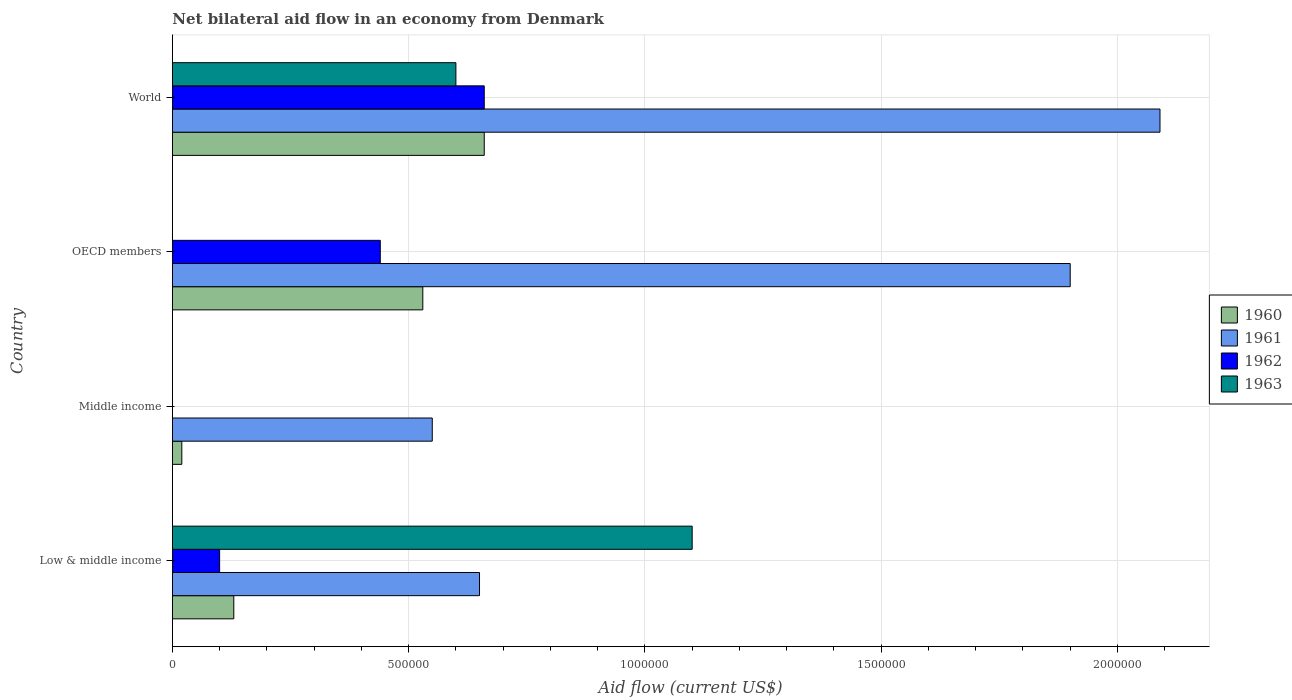How many different coloured bars are there?
Keep it short and to the point. 4. What is the label of the 4th group of bars from the top?
Your answer should be compact. Low & middle income. What is the net bilateral aid flow in 1961 in OECD members?
Your answer should be compact. 1.90e+06. Across all countries, what is the maximum net bilateral aid flow in 1960?
Offer a very short reply. 6.60e+05. What is the total net bilateral aid flow in 1960 in the graph?
Ensure brevity in your answer.  1.34e+06. What is the difference between the net bilateral aid flow in 1963 in Low & middle income and that in World?
Provide a succinct answer. 5.00e+05. What is the difference between the net bilateral aid flow in 1962 in OECD members and the net bilateral aid flow in 1960 in Middle income?
Keep it short and to the point. 4.20e+05. In how many countries, is the net bilateral aid flow in 1960 greater than 100000 US$?
Offer a very short reply. 3. What is the ratio of the net bilateral aid flow in 1961 in Low & middle income to that in World?
Give a very brief answer. 0.31. Is the net bilateral aid flow in 1960 in Low & middle income less than that in Middle income?
Your response must be concise. No. Is the difference between the net bilateral aid flow in 1962 in Low & middle income and World greater than the difference between the net bilateral aid flow in 1963 in Low & middle income and World?
Your answer should be compact. No. What is the difference between the highest and the lowest net bilateral aid flow in 1960?
Offer a very short reply. 6.40e+05. In how many countries, is the net bilateral aid flow in 1962 greater than the average net bilateral aid flow in 1962 taken over all countries?
Provide a succinct answer. 2. Is the sum of the net bilateral aid flow in 1961 in Middle income and OECD members greater than the maximum net bilateral aid flow in 1960 across all countries?
Offer a very short reply. Yes. Is it the case that in every country, the sum of the net bilateral aid flow in 1961 and net bilateral aid flow in 1960 is greater than the net bilateral aid flow in 1963?
Your response must be concise. No. Are the values on the major ticks of X-axis written in scientific E-notation?
Your answer should be compact. No. Does the graph contain any zero values?
Your answer should be compact. Yes. Where does the legend appear in the graph?
Provide a short and direct response. Center right. How many legend labels are there?
Your answer should be very brief. 4. What is the title of the graph?
Provide a succinct answer. Net bilateral aid flow in an economy from Denmark. What is the label or title of the X-axis?
Give a very brief answer. Aid flow (current US$). What is the label or title of the Y-axis?
Your answer should be very brief. Country. What is the Aid flow (current US$) of 1961 in Low & middle income?
Your answer should be very brief. 6.50e+05. What is the Aid flow (current US$) of 1962 in Low & middle income?
Ensure brevity in your answer.  1.00e+05. What is the Aid flow (current US$) of 1963 in Low & middle income?
Your answer should be very brief. 1.10e+06. What is the Aid flow (current US$) of 1960 in Middle income?
Provide a short and direct response. 2.00e+04. What is the Aid flow (current US$) of 1960 in OECD members?
Give a very brief answer. 5.30e+05. What is the Aid flow (current US$) of 1961 in OECD members?
Your answer should be very brief. 1.90e+06. What is the Aid flow (current US$) of 1962 in OECD members?
Give a very brief answer. 4.40e+05. What is the Aid flow (current US$) of 1963 in OECD members?
Your response must be concise. 0. What is the Aid flow (current US$) of 1961 in World?
Offer a terse response. 2.09e+06. What is the Aid flow (current US$) in 1962 in World?
Your answer should be compact. 6.60e+05. What is the Aid flow (current US$) in 1963 in World?
Provide a short and direct response. 6.00e+05. Across all countries, what is the maximum Aid flow (current US$) in 1960?
Offer a terse response. 6.60e+05. Across all countries, what is the maximum Aid flow (current US$) of 1961?
Your answer should be very brief. 2.09e+06. Across all countries, what is the maximum Aid flow (current US$) of 1962?
Your answer should be compact. 6.60e+05. Across all countries, what is the maximum Aid flow (current US$) of 1963?
Make the answer very short. 1.10e+06. Across all countries, what is the minimum Aid flow (current US$) in 1962?
Provide a succinct answer. 0. Across all countries, what is the minimum Aid flow (current US$) in 1963?
Provide a succinct answer. 0. What is the total Aid flow (current US$) of 1960 in the graph?
Provide a short and direct response. 1.34e+06. What is the total Aid flow (current US$) of 1961 in the graph?
Keep it short and to the point. 5.19e+06. What is the total Aid flow (current US$) of 1962 in the graph?
Keep it short and to the point. 1.20e+06. What is the total Aid flow (current US$) in 1963 in the graph?
Provide a short and direct response. 1.70e+06. What is the difference between the Aid flow (current US$) in 1960 in Low & middle income and that in Middle income?
Ensure brevity in your answer.  1.10e+05. What is the difference between the Aid flow (current US$) of 1961 in Low & middle income and that in Middle income?
Provide a succinct answer. 1.00e+05. What is the difference between the Aid flow (current US$) of 1960 in Low & middle income and that in OECD members?
Your answer should be compact. -4.00e+05. What is the difference between the Aid flow (current US$) of 1961 in Low & middle income and that in OECD members?
Make the answer very short. -1.25e+06. What is the difference between the Aid flow (current US$) in 1962 in Low & middle income and that in OECD members?
Ensure brevity in your answer.  -3.40e+05. What is the difference between the Aid flow (current US$) in 1960 in Low & middle income and that in World?
Make the answer very short. -5.30e+05. What is the difference between the Aid flow (current US$) of 1961 in Low & middle income and that in World?
Offer a very short reply. -1.44e+06. What is the difference between the Aid flow (current US$) of 1962 in Low & middle income and that in World?
Your response must be concise. -5.60e+05. What is the difference between the Aid flow (current US$) in 1963 in Low & middle income and that in World?
Keep it short and to the point. 5.00e+05. What is the difference between the Aid flow (current US$) in 1960 in Middle income and that in OECD members?
Your response must be concise. -5.10e+05. What is the difference between the Aid flow (current US$) of 1961 in Middle income and that in OECD members?
Give a very brief answer. -1.35e+06. What is the difference between the Aid flow (current US$) in 1960 in Middle income and that in World?
Your answer should be compact. -6.40e+05. What is the difference between the Aid flow (current US$) of 1961 in Middle income and that in World?
Give a very brief answer. -1.54e+06. What is the difference between the Aid flow (current US$) in 1960 in OECD members and that in World?
Your response must be concise. -1.30e+05. What is the difference between the Aid flow (current US$) in 1961 in OECD members and that in World?
Your response must be concise. -1.90e+05. What is the difference between the Aid flow (current US$) in 1962 in OECD members and that in World?
Make the answer very short. -2.20e+05. What is the difference between the Aid flow (current US$) of 1960 in Low & middle income and the Aid flow (current US$) of 1961 in Middle income?
Provide a succinct answer. -4.20e+05. What is the difference between the Aid flow (current US$) in 1960 in Low & middle income and the Aid flow (current US$) in 1961 in OECD members?
Offer a very short reply. -1.77e+06. What is the difference between the Aid flow (current US$) in 1960 in Low & middle income and the Aid flow (current US$) in 1962 in OECD members?
Your answer should be compact. -3.10e+05. What is the difference between the Aid flow (current US$) in 1960 in Low & middle income and the Aid flow (current US$) in 1961 in World?
Offer a very short reply. -1.96e+06. What is the difference between the Aid flow (current US$) of 1960 in Low & middle income and the Aid flow (current US$) of 1962 in World?
Ensure brevity in your answer.  -5.30e+05. What is the difference between the Aid flow (current US$) in 1960 in Low & middle income and the Aid flow (current US$) in 1963 in World?
Your answer should be very brief. -4.70e+05. What is the difference between the Aid flow (current US$) of 1962 in Low & middle income and the Aid flow (current US$) of 1963 in World?
Give a very brief answer. -5.00e+05. What is the difference between the Aid flow (current US$) of 1960 in Middle income and the Aid flow (current US$) of 1961 in OECD members?
Ensure brevity in your answer.  -1.88e+06. What is the difference between the Aid flow (current US$) in 1960 in Middle income and the Aid flow (current US$) in 1962 in OECD members?
Give a very brief answer. -4.20e+05. What is the difference between the Aid flow (current US$) in 1960 in Middle income and the Aid flow (current US$) in 1961 in World?
Your answer should be compact. -2.07e+06. What is the difference between the Aid flow (current US$) in 1960 in Middle income and the Aid flow (current US$) in 1962 in World?
Keep it short and to the point. -6.40e+05. What is the difference between the Aid flow (current US$) of 1960 in Middle income and the Aid flow (current US$) of 1963 in World?
Ensure brevity in your answer.  -5.80e+05. What is the difference between the Aid flow (current US$) in 1961 in Middle income and the Aid flow (current US$) in 1962 in World?
Provide a succinct answer. -1.10e+05. What is the difference between the Aid flow (current US$) of 1961 in Middle income and the Aid flow (current US$) of 1963 in World?
Offer a very short reply. -5.00e+04. What is the difference between the Aid flow (current US$) in 1960 in OECD members and the Aid flow (current US$) in 1961 in World?
Offer a terse response. -1.56e+06. What is the difference between the Aid flow (current US$) in 1961 in OECD members and the Aid flow (current US$) in 1962 in World?
Your answer should be very brief. 1.24e+06. What is the difference between the Aid flow (current US$) of 1961 in OECD members and the Aid flow (current US$) of 1963 in World?
Give a very brief answer. 1.30e+06. What is the average Aid flow (current US$) in 1960 per country?
Offer a terse response. 3.35e+05. What is the average Aid flow (current US$) in 1961 per country?
Provide a short and direct response. 1.30e+06. What is the average Aid flow (current US$) in 1963 per country?
Give a very brief answer. 4.25e+05. What is the difference between the Aid flow (current US$) in 1960 and Aid flow (current US$) in 1961 in Low & middle income?
Give a very brief answer. -5.20e+05. What is the difference between the Aid flow (current US$) of 1960 and Aid flow (current US$) of 1962 in Low & middle income?
Give a very brief answer. 3.00e+04. What is the difference between the Aid flow (current US$) in 1960 and Aid flow (current US$) in 1963 in Low & middle income?
Keep it short and to the point. -9.70e+05. What is the difference between the Aid flow (current US$) of 1961 and Aid flow (current US$) of 1962 in Low & middle income?
Give a very brief answer. 5.50e+05. What is the difference between the Aid flow (current US$) of 1961 and Aid flow (current US$) of 1963 in Low & middle income?
Your response must be concise. -4.50e+05. What is the difference between the Aid flow (current US$) in 1960 and Aid flow (current US$) in 1961 in Middle income?
Provide a succinct answer. -5.30e+05. What is the difference between the Aid flow (current US$) in 1960 and Aid flow (current US$) in 1961 in OECD members?
Make the answer very short. -1.37e+06. What is the difference between the Aid flow (current US$) of 1960 and Aid flow (current US$) of 1962 in OECD members?
Your answer should be compact. 9.00e+04. What is the difference between the Aid flow (current US$) in 1961 and Aid flow (current US$) in 1962 in OECD members?
Keep it short and to the point. 1.46e+06. What is the difference between the Aid flow (current US$) of 1960 and Aid flow (current US$) of 1961 in World?
Ensure brevity in your answer.  -1.43e+06. What is the difference between the Aid flow (current US$) of 1961 and Aid flow (current US$) of 1962 in World?
Your answer should be compact. 1.43e+06. What is the difference between the Aid flow (current US$) in 1961 and Aid flow (current US$) in 1963 in World?
Provide a succinct answer. 1.49e+06. What is the ratio of the Aid flow (current US$) of 1961 in Low & middle income to that in Middle income?
Your answer should be very brief. 1.18. What is the ratio of the Aid flow (current US$) in 1960 in Low & middle income to that in OECD members?
Provide a succinct answer. 0.25. What is the ratio of the Aid flow (current US$) in 1961 in Low & middle income to that in OECD members?
Your answer should be compact. 0.34. What is the ratio of the Aid flow (current US$) in 1962 in Low & middle income to that in OECD members?
Your answer should be compact. 0.23. What is the ratio of the Aid flow (current US$) of 1960 in Low & middle income to that in World?
Your response must be concise. 0.2. What is the ratio of the Aid flow (current US$) of 1961 in Low & middle income to that in World?
Provide a short and direct response. 0.31. What is the ratio of the Aid flow (current US$) in 1962 in Low & middle income to that in World?
Provide a short and direct response. 0.15. What is the ratio of the Aid flow (current US$) of 1963 in Low & middle income to that in World?
Your response must be concise. 1.83. What is the ratio of the Aid flow (current US$) in 1960 in Middle income to that in OECD members?
Provide a short and direct response. 0.04. What is the ratio of the Aid flow (current US$) in 1961 in Middle income to that in OECD members?
Your response must be concise. 0.29. What is the ratio of the Aid flow (current US$) in 1960 in Middle income to that in World?
Your response must be concise. 0.03. What is the ratio of the Aid flow (current US$) in 1961 in Middle income to that in World?
Provide a short and direct response. 0.26. What is the ratio of the Aid flow (current US$) in 1960 in OECD members to that in World?
Your response must be concise. 0.8. What is the difference between the highest and the second highest Aid flow (current US$) in 1962?
Ensure brevity in your answer.  2.20e+05. What is the difference between the highest and the lowest Aid flow (current US$) in 1960?
Provide a succinct answer. 6.40e+05. What is the difference between the highest and the lowest Aid flow (current US$) in 1961?
Keep it short and to the point. 1.54e+06. What is the difference between the highest and the lowest Aid flow (current US$) of 1962?
Your response must be concise. 6.60e+05. What is the difference between the highest and the lowest Aid flow (current US$) in 1963?
Provide a short and direct response. 1.10e+06. 